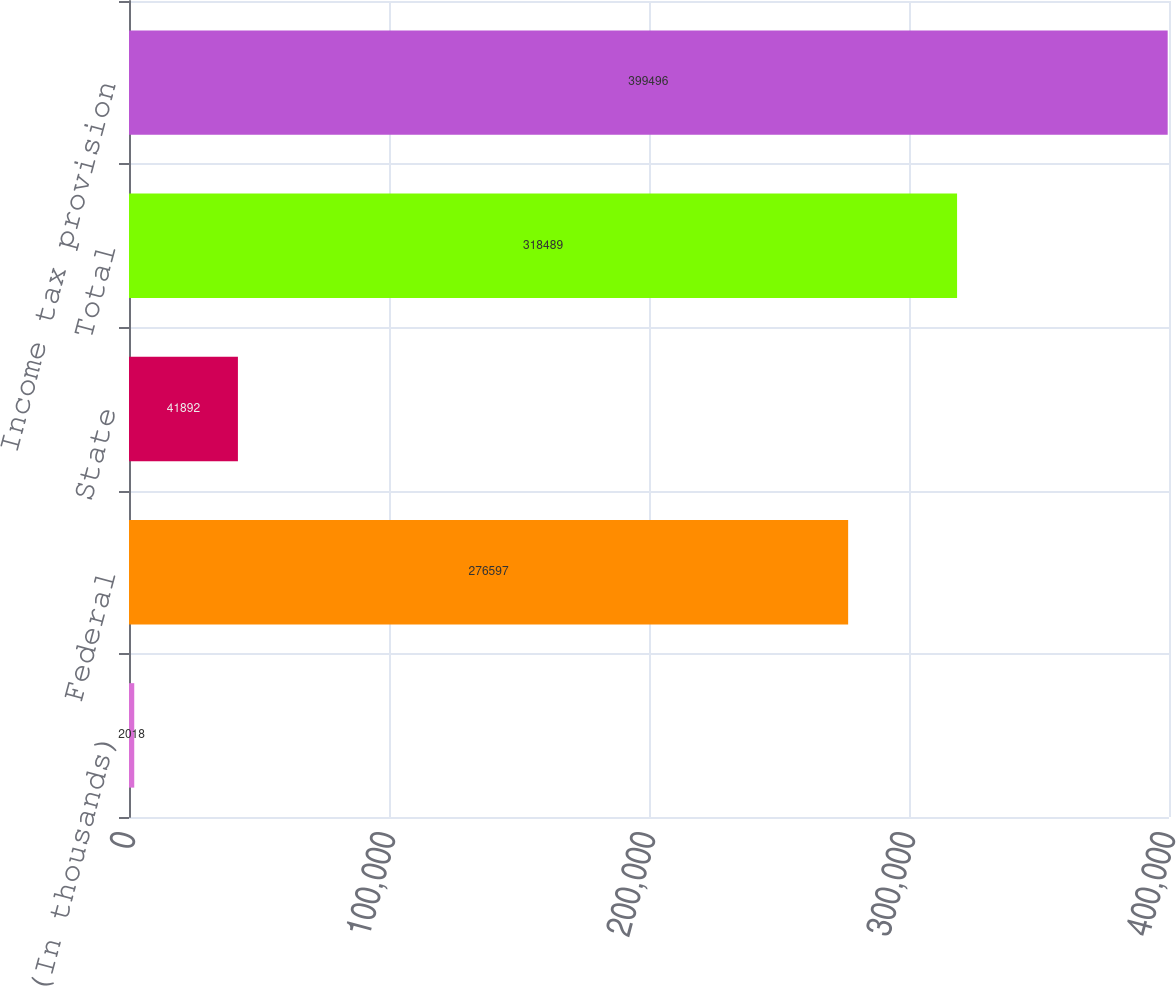Convert chart to OTSL. <chart><loc_0><loc_0><loc_500><loc_500><bar_chart><fcel>(In thousands)<fcel>Federal<fcel>State<fcel>Total<fcel>Income tax provision<nl><fcel>2018<fcel>276597<fcel>41892<fcel>318489<fcel>399496<nl></chart> 